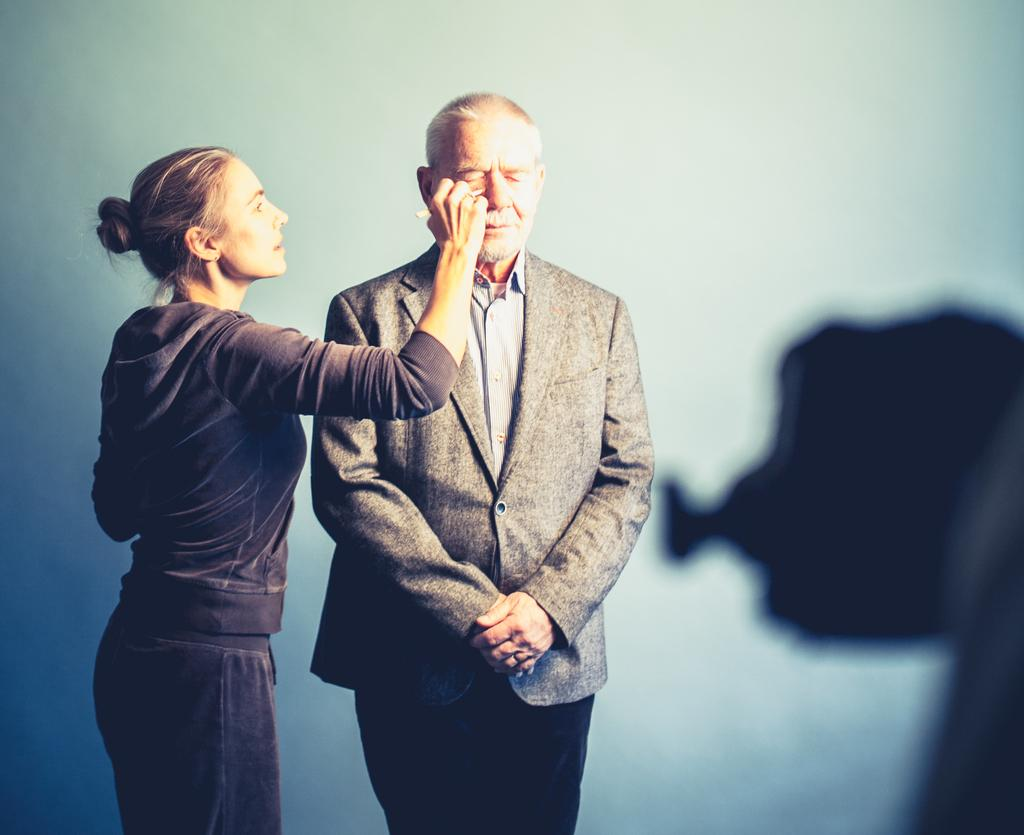Who is the main subject in the image? The main subject in the image is an old man. What is the old man wearing? The old man is wearing a grey suit. Where is the old man positioned in the image? The old man is standing in the front. Who else is present in the image? There is a woman in the image. What is the woman doing to the old man? The woman is doing makeup to the old man. What can be seen in the background of the image? There is a white wall in the background of the image. What type of fruit is the old man holding in the image? There is no fruit present in the image; the old man is not holding any fruit. 